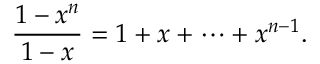<formula> <loc_0><loc_0><loc_500><loc_500>{ \frac { 1 - x ^ { n } } { 1 - x } } = 1 + x + \cdots + x ^ { n - 1 } .</formula> 